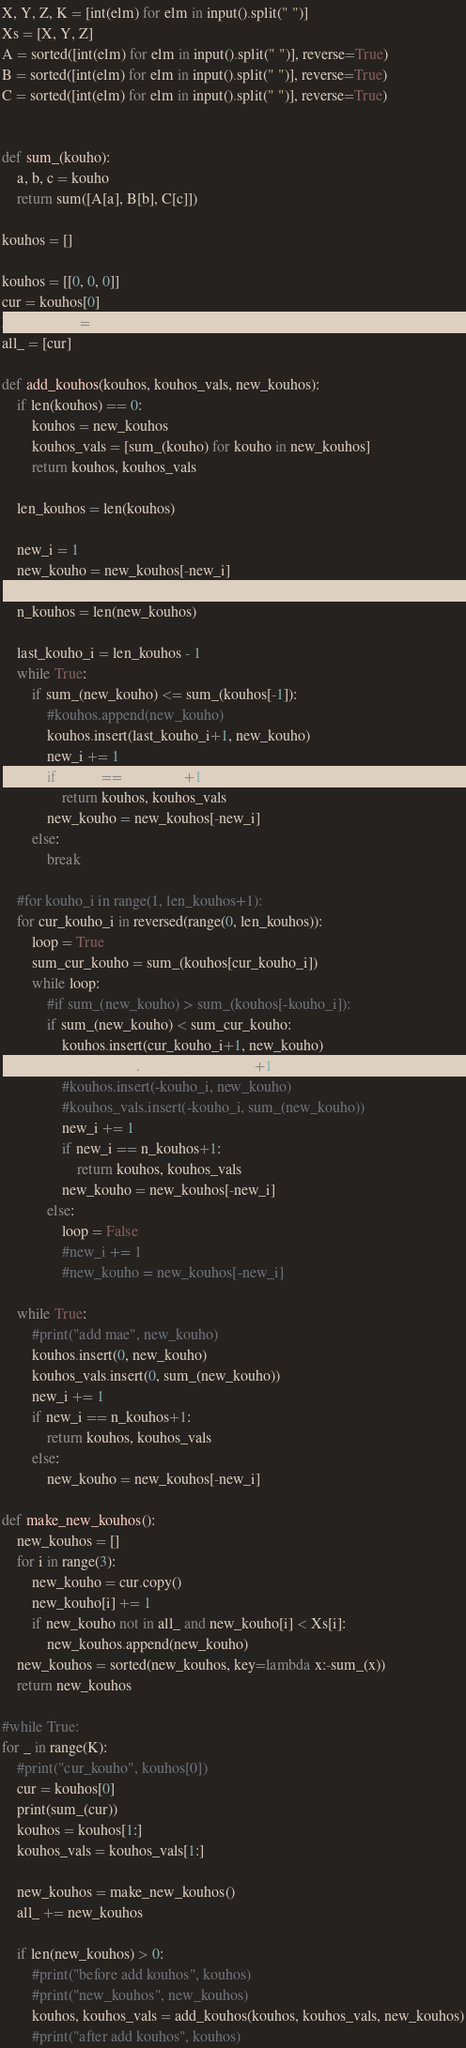Convert code to text. <code><loc_0><loc_0><loc_500><loc_500><_Python_>X, Y, Z, K = [int(elm) for elm in input().split(" ")]
Xs = [X, Y, Z]
A = sorted([int(elm) for elm in input().split(" ")], reverse=True)
B = sorted([int(elm) for elm in input().split(" ")], reverse=True)
C = sorted([int(elm) for elm in input().split(" ")], reverse=True)


def sum_(kouho):
    a, b, c = kouho
    return sum([A[a], B[b], C[c]])

kouhos = []

kouhos = [[0, 0, 0]]
cur = kouhos[0]
kouhos_vals = [sum_(cur)]
all_ = [cur]

def add_kouhos(kouhos, kouhos_vals, new_kouhos):
    if len(kouhos) == 0:
        kouhos = new_kouhos
        kouhos_vals = [sum_(kouho) for kouho in new_kouhos]
        return kouhos, kouhos_vals

    len_kouhos = len(kouhos)

    new_i = 1
    new_kouho = new_kouhos[-new_i] 

    n_kouhos = len(new_kouhos)

    last_kouho_i = len_kouhos - 1
    while True:
        if sum_(new_kouho) <= sum_(kouhos[-1]):
            #kouhos.append(new_kouho)
            kouhos.insert(last_kouho_i+1, new_kouho)
            new_i += 1
            if new_i == n_kouhos+1:
                return kouhos, kouhos_vals        
            new_kouho = new_kouhos[-new_i]
        else:
            break

    #for kouho_i in range(1, len_kouhos+1):
    for cur_kouho_i in reversed(range(0, len_kouhos)):
        loop = True
        sum_cur_kouho = sum_(kouhos[cur_kouho_i])
        while loop:
            #if sum_(new_kouho) > sum_(kouhos[-kouho_i]):
            if sum_(new_kouho) < sum_cur_kouho: 
                kouhos.insert(cur_kouho_i+1, new_kouho)
                kouhos_vals.insert(cur_kouho_i+1, sum_(new_kouho))
                #kouhos.insert(-kouho_i, new_kouho)
                #kouhos_vals.insert(-kouho_i, sum_(new_kouho))
                new_i += 1
                if new_i == n_kouhos+1:
                    return kouhos, kouhos_vals
                new_kouho = new_kouhos[-new_i]
            else:
                loop = False
                #new_i += 1
                #new_kouho = new_kouhos[-new_i]

    while True:
        #print("add mae", new_kouho)
        kouhos.insert(0, new_kouho) 
        kouhos_vals.insert(0, sum_(new_kouho))
        new_i += 1
        if new_i == n_kouhos+1:
            return kouhos, kouhos_vals
        else:
            new_kouho = new_kouhos[-new_i]

def make_new_kouhos():
    new_kouhos = []
    for i in range(3):
        new_kouho = cur.copy()
        new_kouho[i] += 1
        if new_kouho not in all_ and new_kouho[i] < Xs[i]:
            new_kouhos.append(new_kouho)
    new_kouhos = sorted(new_kouhos, key=lambda x:-sum_(x))
    return new_kouhos

#while True:
for _ in range(K):
    #print("cur_kouho", kouhos[0])
    cur = kouhos[0]
    print(sum_(cur))
    kouhos = kouhos[1:]
    kouhos_vals = kouhos_vals[1:]

    new_kouhos = make_new_kouhos()
    all_ += new_kouhos

    if len(new_kouhos) > 0:
        #print("before add kouhos", kouhos)
        #print("new_kouhos", new_kouhos)
        kouhos, kouhos_vals = add_kouhos(kouhos, kouhos_vals, new_kouhos)
        #print("after add kouhos", kouhos)
</code> 